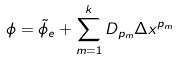<formula> <loc_0><loc_0><loc_500><loc_500>\phi = \tilde { \phi } _ { e } + \sum _ { m = 1 } ^ { k } D _ { p _ { m } } \Delta x ^ { p _ { m } }</formula> 